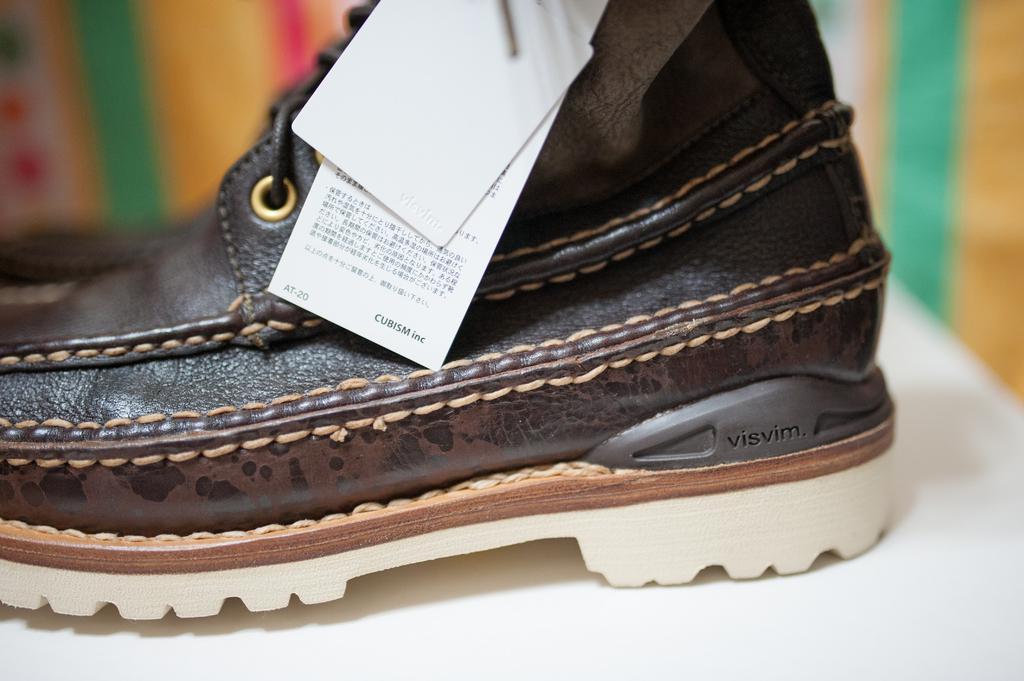Can you describe this image briefly? In this image there is a shoe with tag. The background is blurry. 